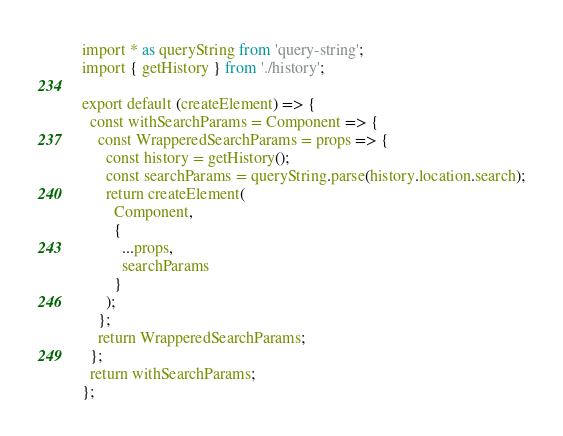Convert code to text. <code><loc_0><loc_0><loc_500><loc_500><_TypeScript_>import * as queryString from 'query-string';
import { getHistory } from './history';

export default (createElement) => {
  const withSearchParams = Component => {
    const WrapperedSearchParams = props => {
      const history = getHistory();
      const searchParams = queryString.parse(history.location.search);
      return createElement(
        Component,
        {
          ...props,
          searchParams
        }
      );
    };
    return WrapperedSearchParams;
  };
  return withSearchParams;
};
</code> 